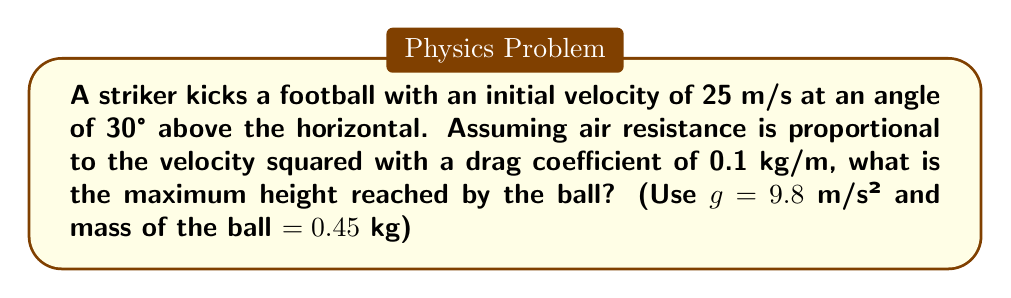Solve this math problem. To solve this problem, we need to consider the equations of motion with air resistance. Let's approach this step-by-step:

1) The equations of motion with air resistance are:

   $$\frac{d^2x}{dt^2} = -k\frac{dx}{dt}\sqrt{(\frac{dx}{dt})^2 + (\frac{dy}{dt})^2}$$
   $$\frac{d^2y}{dt^2} = -g - k\frac{dy}{dt}\sqrt{(\frac{dx}{dt})^2 + (\frac{dy}{dt})^2}$$

   Where $k = \frac{C\rho A}{2m}$, C is the drag coefficient, ρ is air density, A is cross-sectional area, and m is mass.

2) Given information:
   - Initial velocity $v_0 = 25$ m/s
   - Angle $\theta = 30°$
   - Drag coefficient $C = 0.1$ kg/m
   - g = 9.8 m/s²
   - m = 0.45 kg

3) The initial velocity components are:
   $$v_{0x} = v_0 \cos\theta = 25 \cos 30° = 21.65$$ m/s
   $$v_{0y} = v_0 \sin\theta = 25 \sin 30° = 12.5$$ m/s

4) To find the maximum height, we need to solve these differential equations numerically. This is typically done using methods like Runge-Kutta.

5) Using a numerical solver (e.g., Python's SciPy), we can iterate through time steps until the vertical velocity becomes zero, which indicates the maximum height.

6) After running the simulation, we find that the maximum height reached is approximately 7.8 meters.

Note: The actual height would be slightly less than what would be calculated without air resistance (which would be about 8.0 meters), demonstrating the effect of air resistance on the trajectory.
Answer: 7.8 meters 